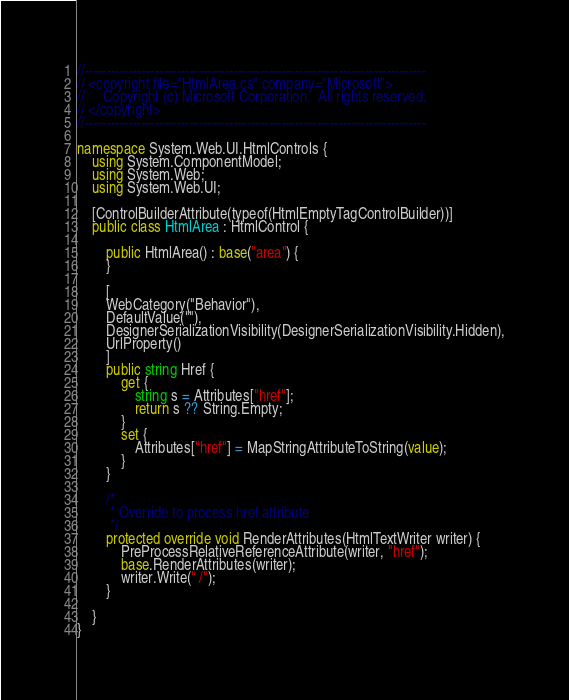<code> <loc_0><loc_0><loc_500><loc_500><_C#_>//------------------------------------------------------------------------------
// <copyright file="HtmlArea.cs" company="Microsoft">
//     Copyright (c) Microsoft Corporation.  All rights reserved.
// </copyright>
//------------------------------------------------------------------------------

namespace System.Web.UI.HtmlControls {
    using System.ComponentModel;
    using System.Web;
    using System.Web.UI;

    [ControlBuilderAttribute(typeof(HtmlEmptyTagControlBuilder))]
    public class HtmlArea : HtmlControl {

        public HtmlArea() : base("area") {
        }

        [
        WebCategory("Behavior"),
        DefaultValue(""),
        DesignerSerializationVisibility(DesignerSerializationVisibility.Hidden),
        UrlProperty()
        ]
        public string Href {
            get {
                string s = Attributes["href"];
                return s ?? String.Empty;
            }
            set {
                Attributes["href"] = MapStringAttributeToString(value);
            }
        }

        /*
         * Override to process href attribute
         */
        protected override void RenderAttributes(HtmlTextWriter writer) {
            PreProcessRelativeReferenceAttribute(writer, "href");
            base.RenderAttributes(writer);
            writer.Write(" /");
        }

    }
}
</code> 